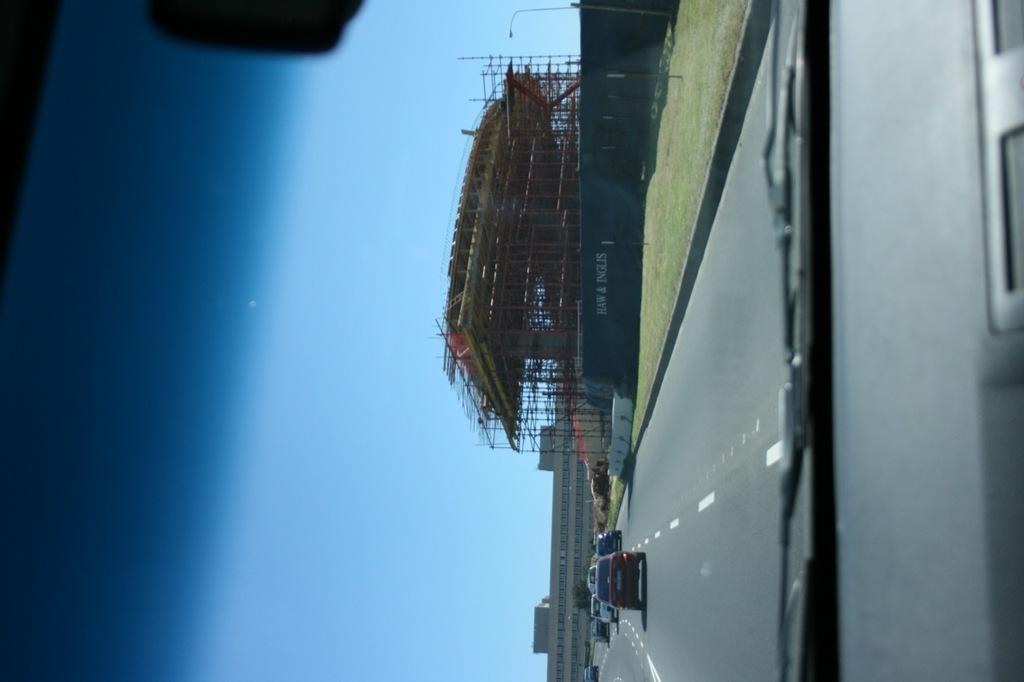What is happening on the road in the image? There are cars moving on the road in the image. What can be seen on the right side of the image? There is a building constructed on the right side in the image. What is visible in the backdrop of the image? There is a building in the backdrop of the image. How would you describe the sky in the image? The sky is clear in the image. How many pizzas are being served at the amusement park in the image? There is no amusement park or pizzas present in the image. What type of bird can be seen flying over the building in the image? There is no bird visible in the image. 